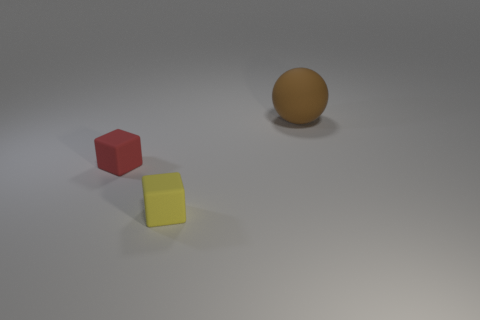Add 2 purple things. How many objects exist? 5 Subtract all balls. How many objects are left? 2 Add 2 small red metal spheres. How many small red metal spheres exist? 2 Subtract 0 purple spheres. How many objects are left? 3 Subtract all big rubber things. Subtract all large cyan metal balls. How many objects are left? 2 Add 2 small matte blocks. How many small matte blocks are left? 4 